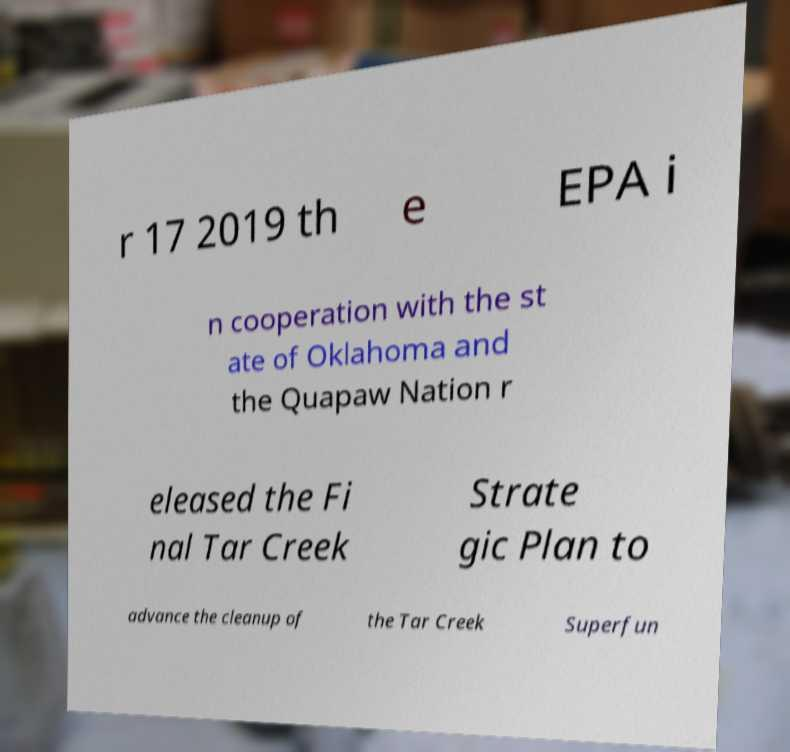Can you read and provide the text displayed in the image?This photo seems to have some interesting text. Can you extract and type it out for me? r 17 2019 th e EPA i n cooperation with the st ate of Oklahoma and the Quapaw Nation r eleased the Fi nal Tar Creek Strate gic Plan to advance the cleanup of the Tar Creek Superfun 